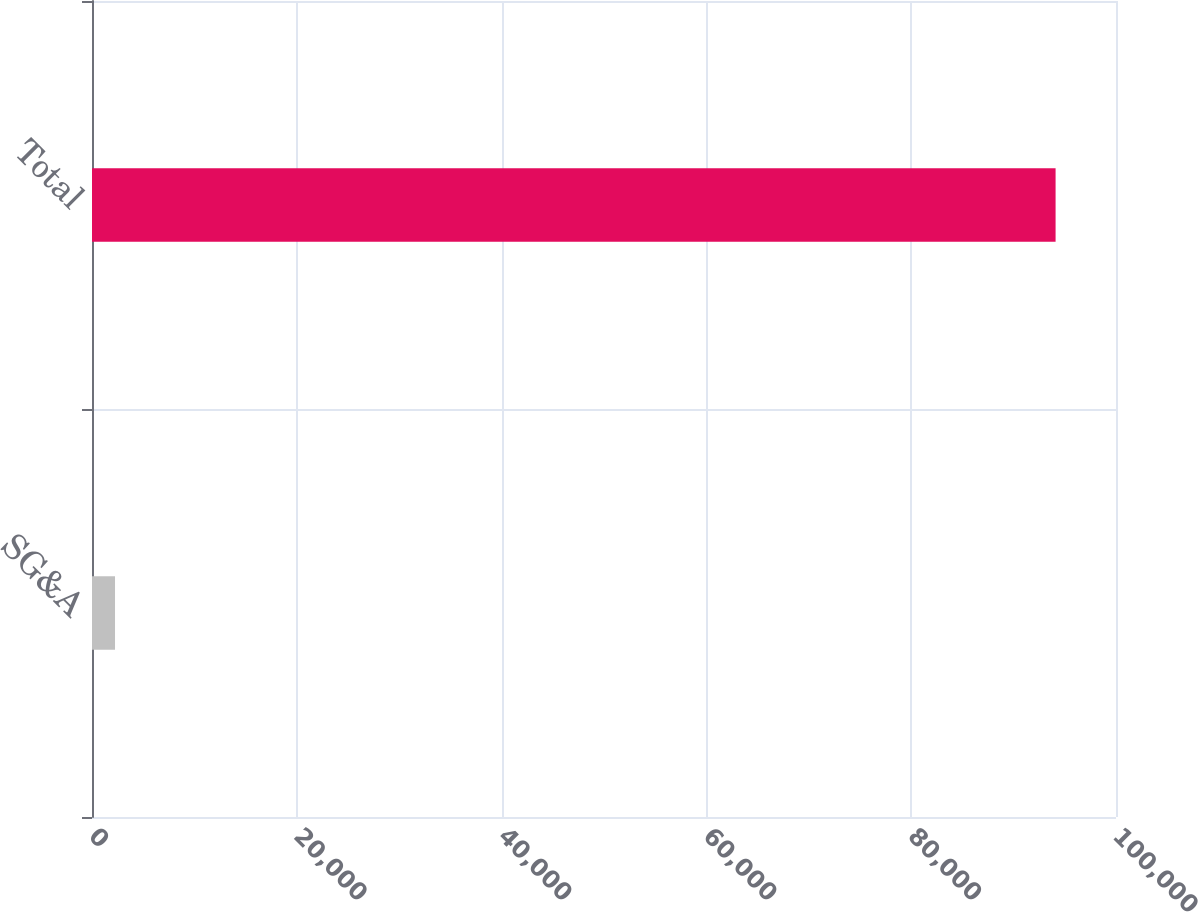Convert chart to OTSL. <chart><loc_0><loc_0><loc_500><loc_500><bar_chart><fcel>SG&A<fcel>Total<nl><fcel>2249<fcel>94100<nl></chart> 